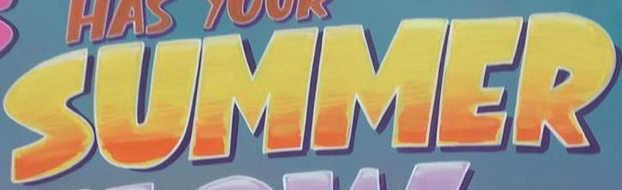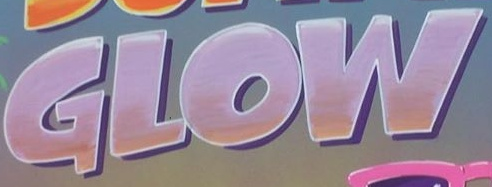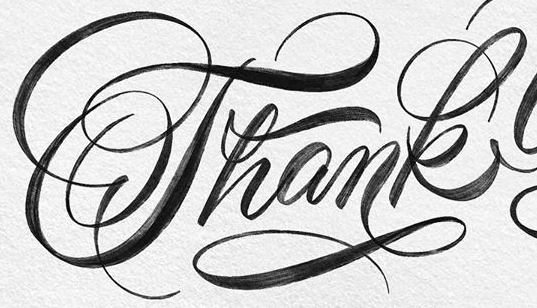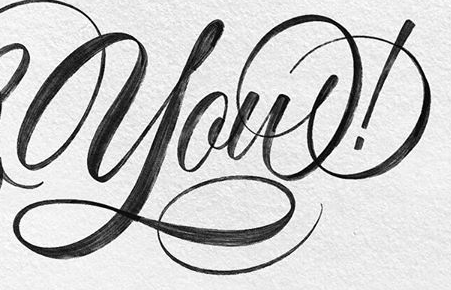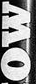What text is displayed in these images sequentially, separated by a semicolon? SUMMER; GLOW; Thank; you!; MO 